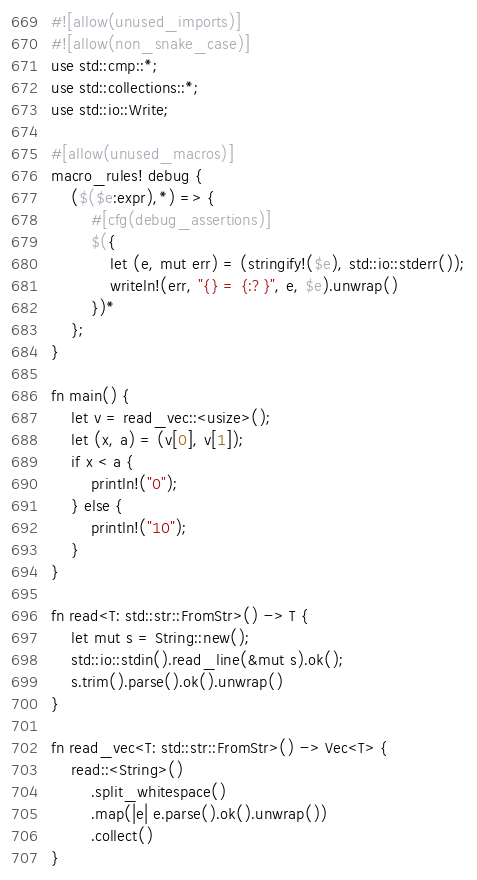Convert code to text. <code><loc_0><loc_0><loc_500><loc_500><_Rust_>#![allow(unused_imports)]
#![allow(non_snake_case)]
use std::cmp::*;
use std::collections::*;
use std::io::Write;

#[allow(unused_macros)]
macro_rules! debug {
    ($($e:expr),*) => {
        #[cfg(debug_assertions)]
        $({
            let (e, mut err) = (stringify!($e), std::io::stderr());
            writeln!(err, "{} = {:?}", e, $e).unwrap()
        })*
    };
}

fn main() {
    let v = read_vec::<usize>();
    let (x, a) = (v[0], v[1]);
    if x < a {
        println!("0");
    } else {
        println!("10");
    }
}

fn read<T: std::str::FromStr>() -> T {
    let mut s = String::new();
    std::io::stdin().read_line(&mut s).ok();
    s.trim().parse().ok().unwrap()
}

fn read_vec<T: std::str::FromStr>() -> Vec<T> {
    read::<String>()
        .split_whitespace()
        .map(|e| e.parse().ok().unwrap())
        .collect()
}
</code> 